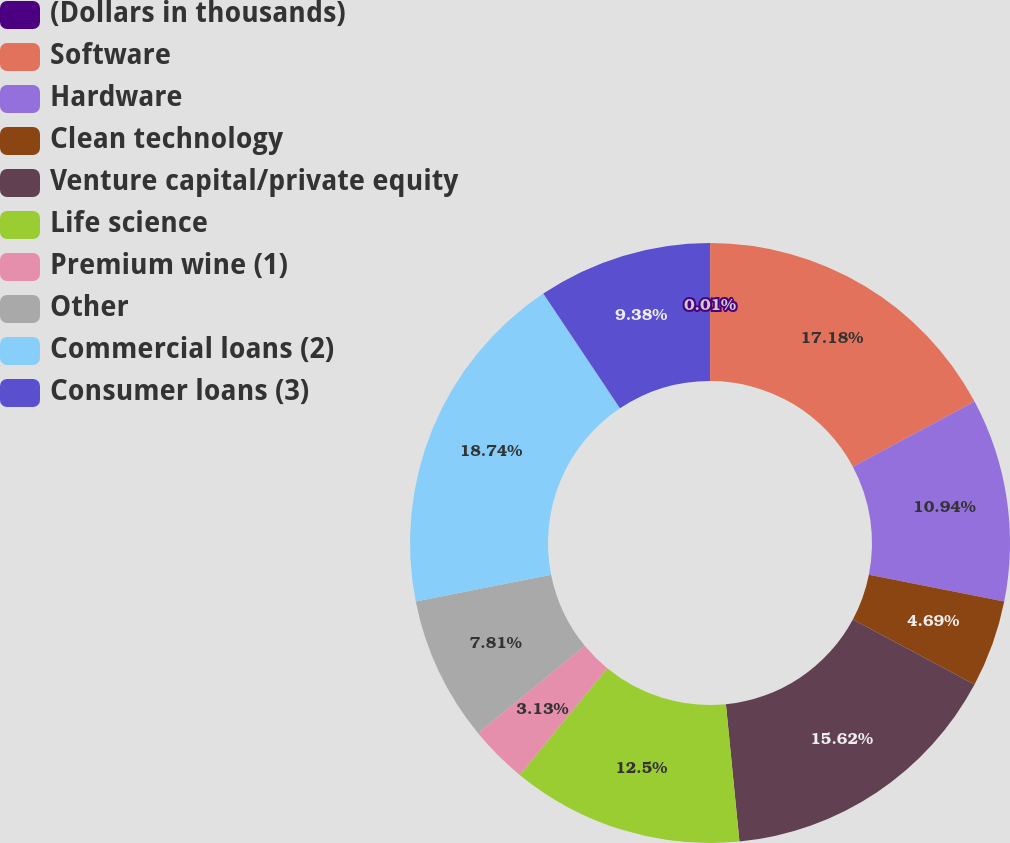Convert chart. <chart><loc_0><loc_0><loc_500><loc_500><pie_chart><fcel>(Dollars in thousands)<fcel>Software<fcel>Hardware<fcel>Clean technology<fcel>Venture capital/private equity<fcel>Life science<fcel>Premium wine (1)<fcel>Other<fcel>Commercial loans (2)<fcel>Consumer loans (3)<nl><fcel>0.01%<fcel>17.18%<fcel>10.94%<fcel>4.69%<fcel>15.62%<fcel>12.5%<fcel>3.13%<fcel>7.81%<fcel>18.75%<fcel>9.38%<nl></chart> 